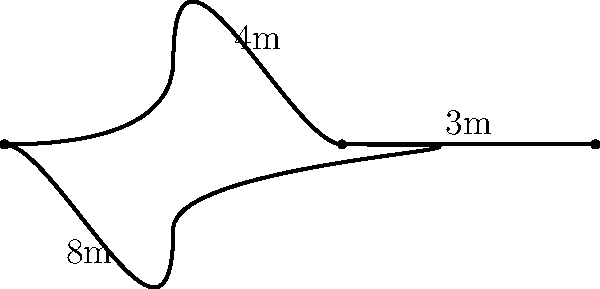At a Latin music-themed resort, there's a guitar-shaped swimming pool inspired by Rauw Alejandro's iconic instruments. The pool's body is shaped like an elongated oval, and the neck extends straight from one end. If the body of the guitar-shaped pool measures 8m in length and 4m at its widest point, and the neck extends an additional 3m, what is the approximate perimeter of the entire pool? To find the perimeter of the guitar-shaped pool, we'll break it down into steps:

1) First, we need to approximate the perimeter of the oval-shaped body. For an elongated oval, we can use the formula:

   $$P_{oval} \approx 2\pi\sqrt{\frac{a^2 + b^2}{2}}$$

   Where $a$ is half the length and $b$ is half the width.

2) In this case, $a = 4$ (half of 8m) and $b = 2$ (half of 4m).

3) Plugging these values into the formula:

   $$P_{oval} \approx 2\pi\sqrt{\frac{4^2 + 2^2}{2}} = 2\pi\sqrt{\frac{20}{2}} = 2\pi\sqrt{10} \approx 19.87m$$

4) Now, we need to account for the neck. The neck extends 3m, but it replaces part of the oval's perimeter. We can estimate this replaced part as approximately 1m.

5) So we add 2m (3m - 1m) to our oval perimeter:

   $$19.87m + 2m = 21.87m$$

6) Rounding to the nearest meter, we get 22m.
Answer: 22m 